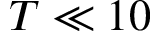Convert formula to latex. <formula><loc_0><loc_0><loc_500><loc_500>T \ll 1 0</formula> 